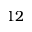<formula> <loc_0><loc_0><loc_500><loc_500>1 2</formula> 